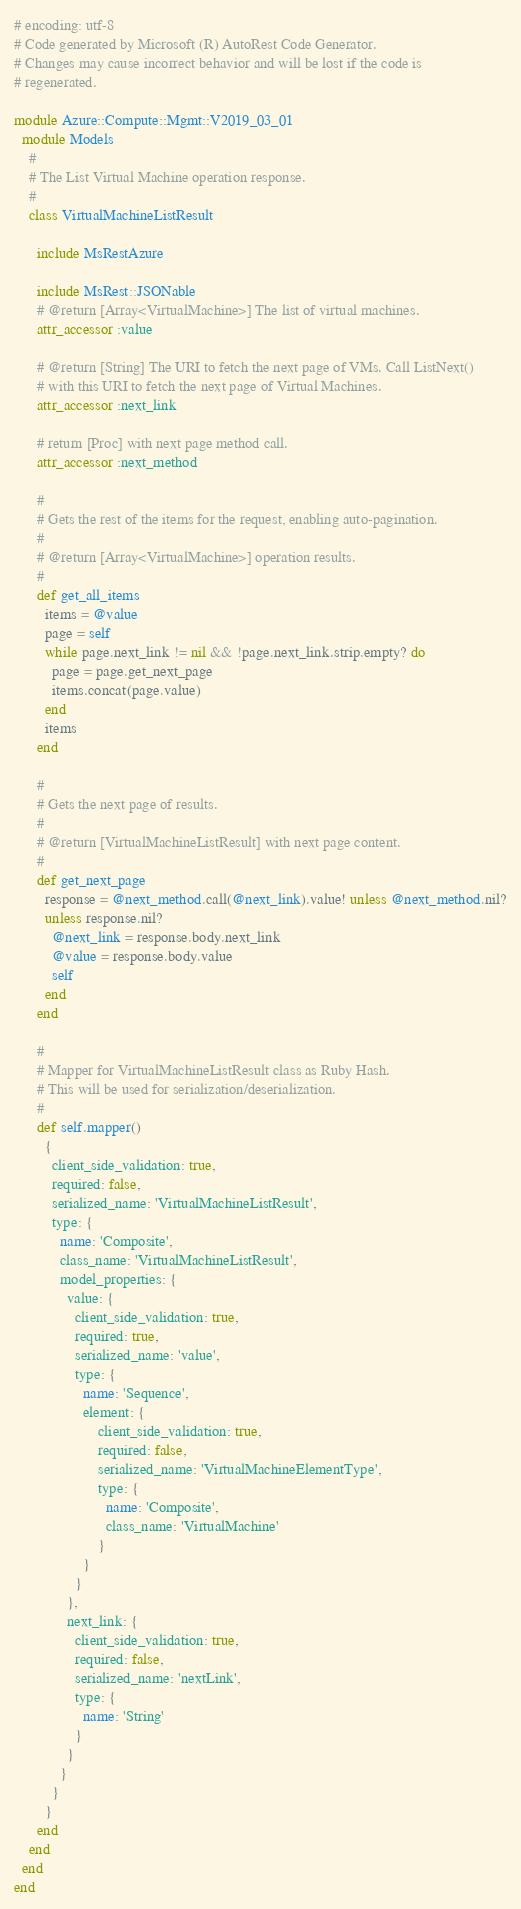<code> <loc_0><loc_0><loc_500><loc_500><_Ruby_># encoding: utf-8
# Code generated by Microsoft (R) AutoRest Code Generator.
# Changes may cause incorrect behavior and will be lost if the code is
# regenerated.

module Azure::Compute::Mgmt::V2019_03_01
  module Models
    #
    # The List Virtual Machine operation response.
    #
    class VirtualMachineListResult

      include MsRestAzure

      include MsRest::JSONable
      # @return [Array<VirtualMachine>] The list of virtual machines.
      attr_accessor :value

      # @return [String] The URI to fetch the next page of VMs. Call ListNext()
      # with this URI to fetch the next page of Virtual Machines.
      attr_accessor :next_link

      # return [Proc] with next page method call.
      attr_accessor :next_method

      #
      # Gets the rest of the items for the request, enabling auto-pagination.
      #
      # @return [Array<VirtualMachine>] operation results.
      #
      def get_all_items
        items = @value
        page = self
        while page.next_link != nil && !page.next_link.strip.empty? do
          page = page.get_next_page
          items.concat(page.value)
        end
        items
      end

      #
      # Gets the next page of results.
      #
      # @return [VirtualMachineListResult] with next page content.
      #
      def get_next_page
        response = @next_method.call(@next_link).value! unless @next_method.nil?
        unless response.nil?
          @next_link = response.body.next_link
          @value = response.body.value
          self
        end
      end

      #
      # Mapper for VirtualMachineListResult class as Ruby Hash.
      # This will be used for serialization/deserialization.
      #
      def self.mapper()
        {
          client_side_validation: true,
          required: false,
          serialized_name: 'VirtualMachineListResult',
          type: {
            name: 'Composite',
            class_name: 'VirtualMachineListResult',
            model_properties: {
              value: {
                client_side_validation: true,
                required: true,
                serialized_name: 'value',
                type: {
                  name: 'Sequence',
                  element: {
                      client_side_validation: true,
                      required: false,
                      serialized_name: 'VirtualMachineElementType',
                      type: {
                        name: 'Composite',
                        class_name: 'VirtualMachine'
                      }
                  }
                }
              },
              next_link: {
                client_side_validation: true,
                required: false,
                serialized_name: 'nextLink',
                type: {
                  name: 'String'
                }
              }
            }
          }
        }
      end
    end
  end
end
</code> 